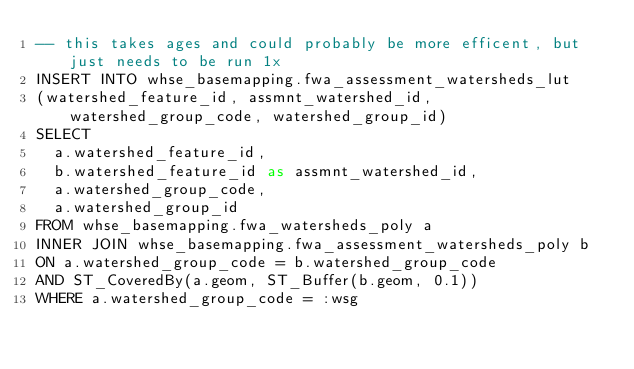Convert code to text. <code><loc_0><loc_0><loc_500><loc_500><_SQL_>-- this takes ages and could probably be more efficent, but just needs to be run 1x
INSERT INTO whse_basemapping.fwa_assessment_watersheds_lut
(watershed_feature_id, assmnt_watershed_id, watershed_group_code, watershed_group_id)
SELECT
  a.watershed_feature_id,
  b.watershed_feature_id as assmnt_watershed_id,
  a.watershed_group_code,
  a.watershed_group_id
FROM whse_basemapping.fwa_watersheds_poly a
INNER JOIN whse_basemapping.fwa_assessment_watersheds_poly b
ON a.watershed_group_code = b.watershed_group_code
AND ST_CoveredBy(a.geom, ST_Buffer(b.geom, 0.1))
WHERE a.watershed_group_code = :wsg</code> 